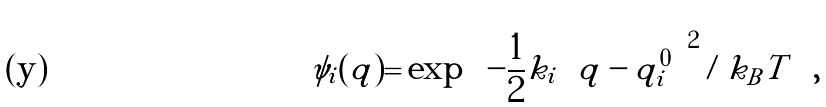<formula> <loc_0><loc_0><loc_500><loc_500>\psi _ { i } ( q ) = \exp \left ( - \frac { 1 } { 2 } k _ { i } \left ( q - q ^ { 0 } _ { i } \right ) ^ { 2 } / k _ { B } T \right ) ,</formula> 